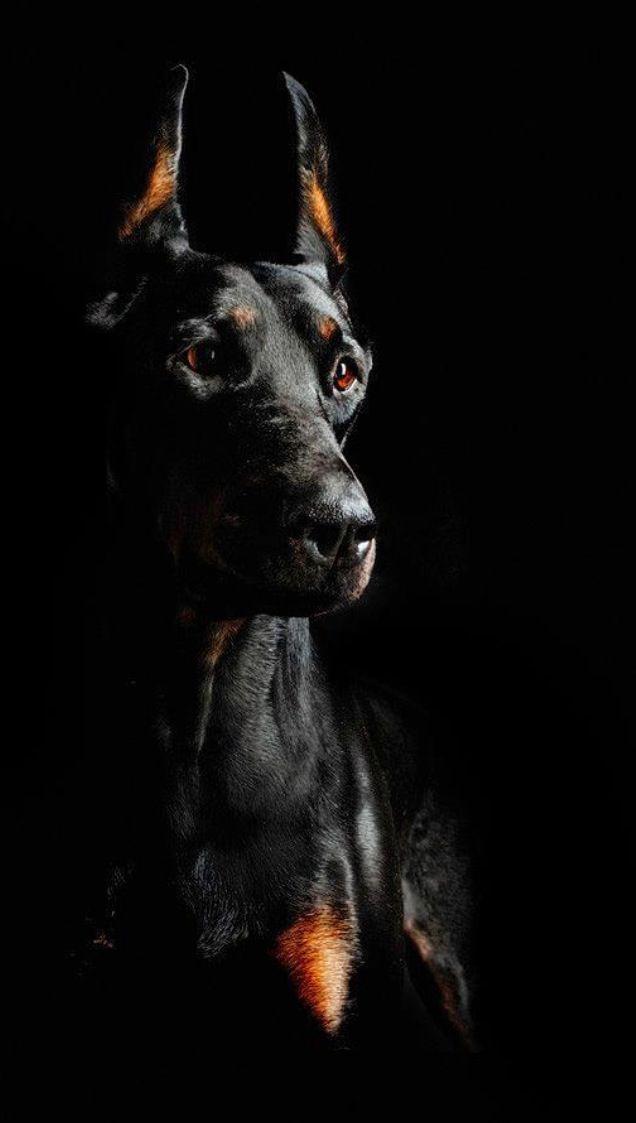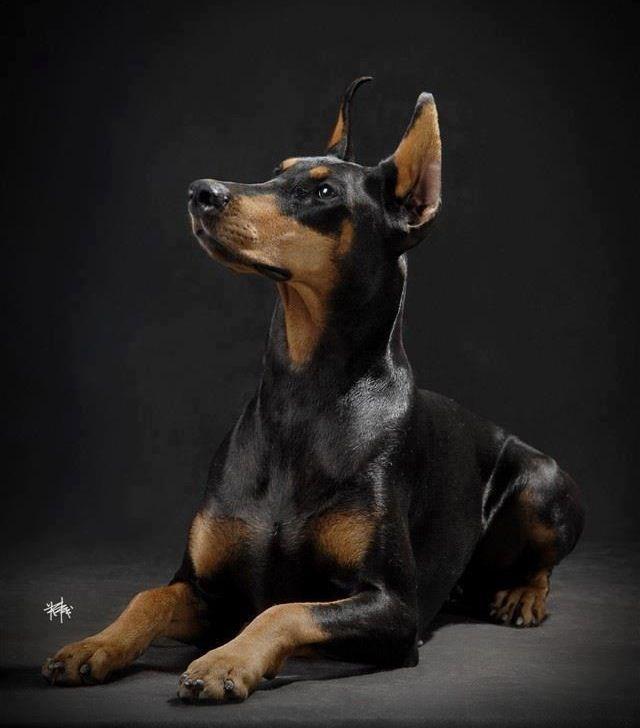The first image is the image on the left, the second image is the image on the right. Considering the images on both sides, is "The combined images include at least four dogs, with at least two dogs in sitting poses and two dogs facing directly forward." valid? Answer yes or no. No. The first image is the image on the left, the second image is the image on the right. Given the left and right images, does the statement "There are dobermans standing." hold true? Answer yes or no. No. 